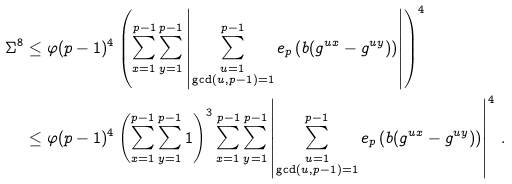<formula> <loc_0><loc_0><loc_500><loc_500>\Sigma ^ { 8 } & \leq \varphi ( p - 1 ) ^ { 4 } \left ( \sum _ { x = 1 } ^ { p - 1 } \sum _ { y = 1 } ^ { p - 1 } \left | \sum _ { \substack { u = 1 \\ \gcd ( u , p - 1 ) = 1 } } ^ { p - 1 } e _ { p } \left ( b ( g ^ { u x } - g ^ { u y } ) \right ) \right | \right ) ^ { 4 } \\ & \leq \varphi ( p - 1 ) ^ { 4 } \left ( \sum _ { x = 1 } ^ { p - 1 } \sum _ { y = 1 } ^ { p - 1 } 1 \right ) ^ { 3 } \sum _ { x = 1 } ^ { p - 1 } \sum _ { y = 1 } ^ { p - 1 } \left | \sum _ { \substack { u = 1 \\ \gcd ( u , p - 1 ) = 1 } } ^ { p - 1 } e _ { p } \left ( b ( g ^ { u x } - g ^ { u y } ) \right ) \right | ^ { 4 } \, .</formula> 